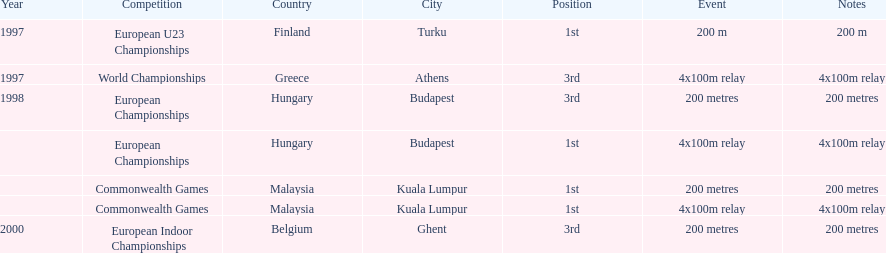In what year between 1997 and 2000 did julian golding, the sprinter representing the united kingdom and england finish first in both the 4 x 100 m relay and the 200 metres race? 1998. 